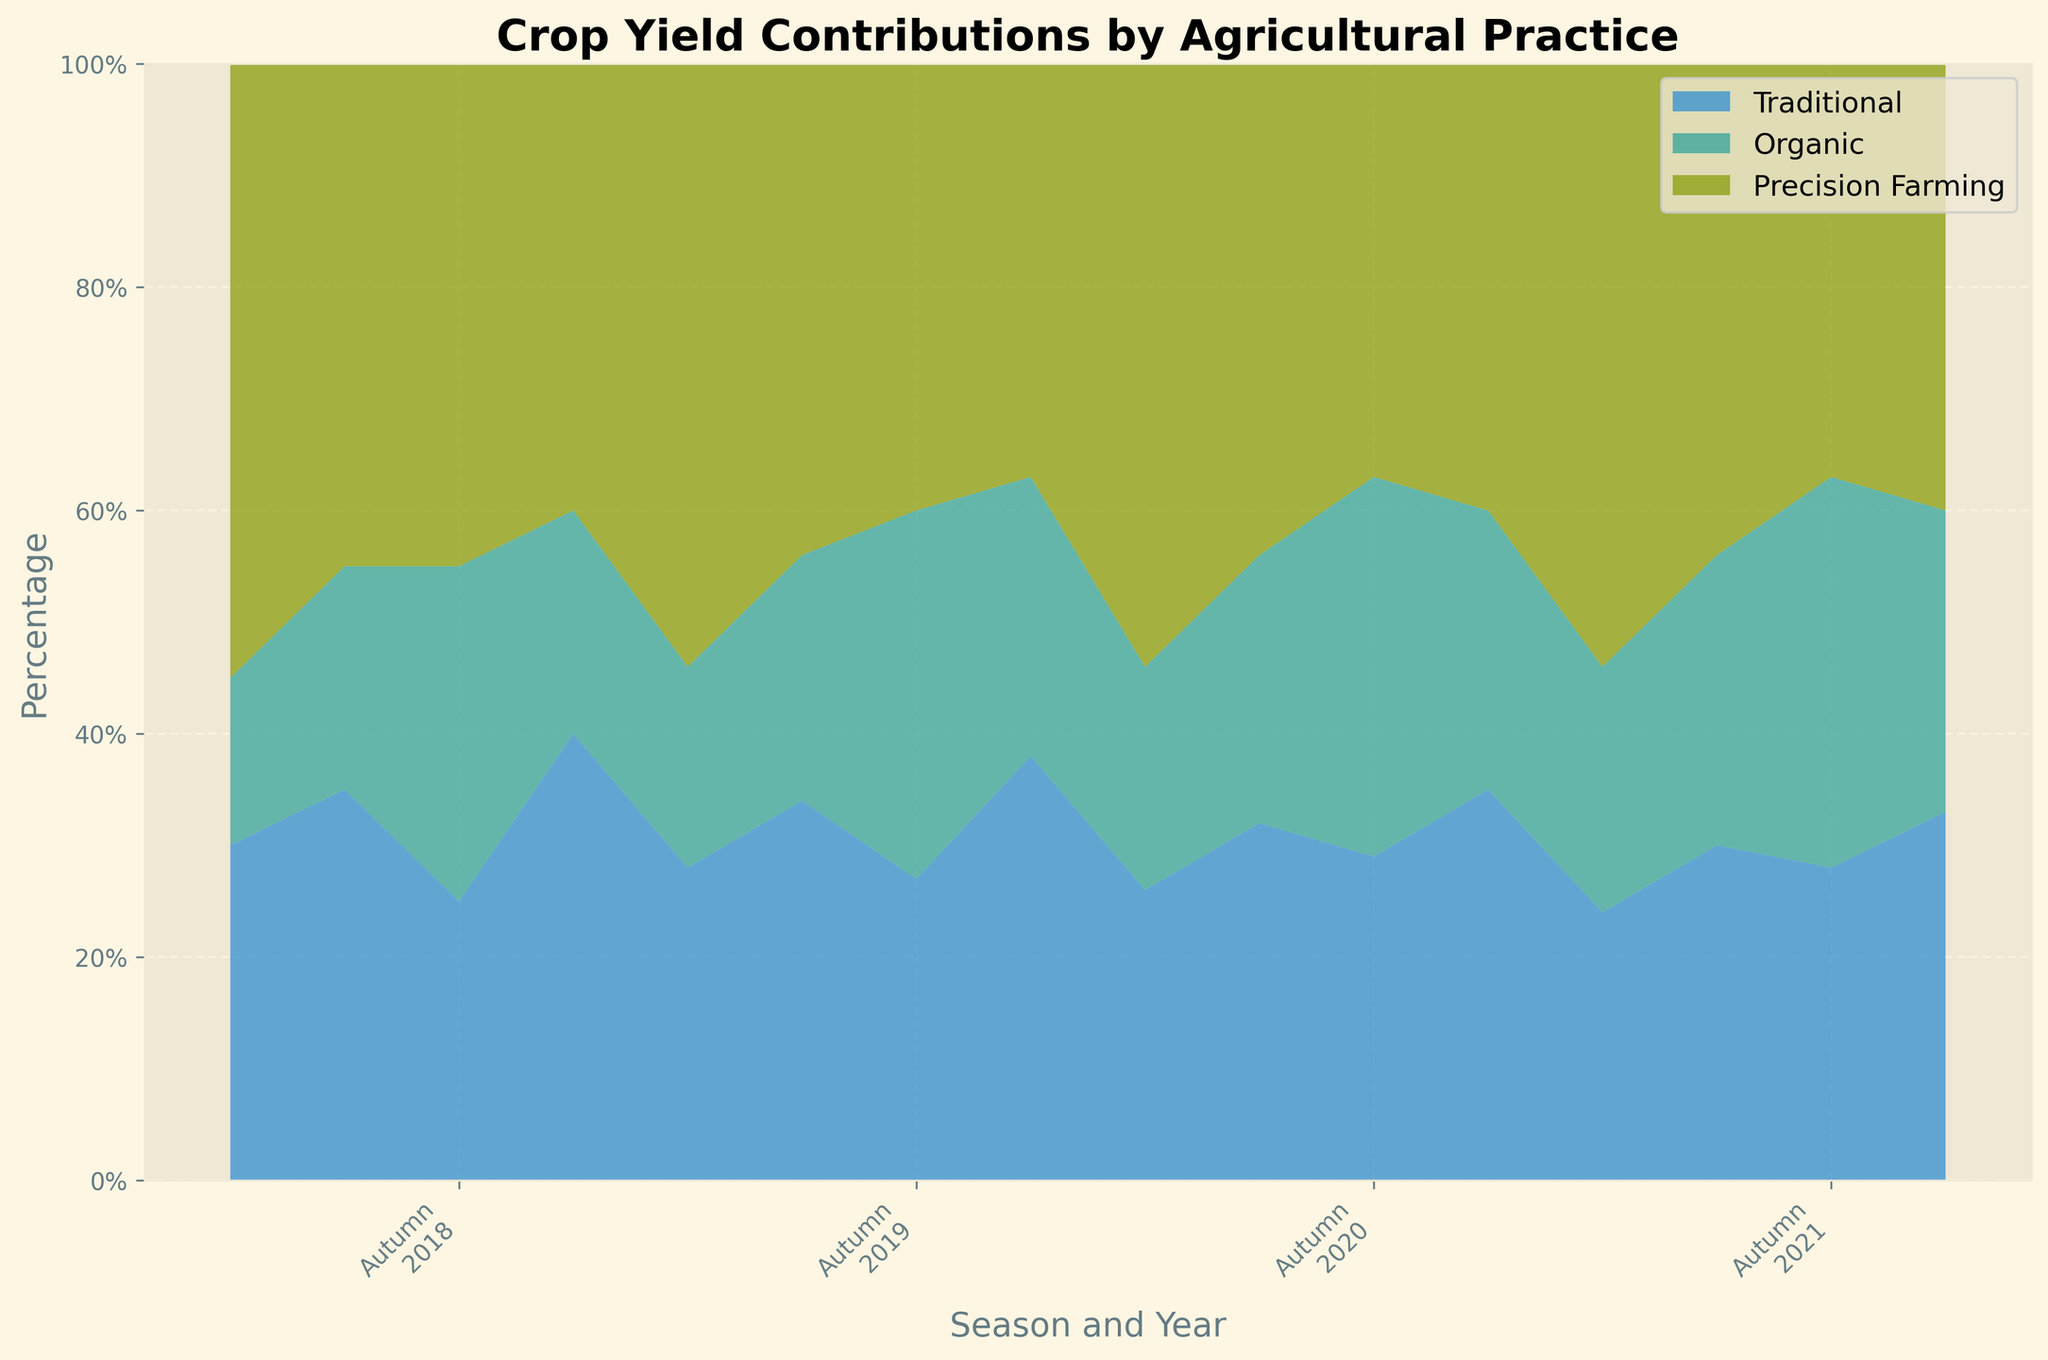What is the title of the chart? The title is usually found at the top of the chart. It provides a brief description of what the chart is about. In this case, the title is "Crop Yield Contributions by Agricultural Practice".
Answer: Crop Yield Contributions by Agricultural Practice Which seasons and years are represented in the x-axis of the chart? Upon examining the x-axis, we can identify that it includes seasons (Spring, Summer, Autumn, Winter) and years (2018, 2019, 2020, 2021).
Answer: Spring, Summer, Autumn, Winter for the years 2018, 2019, 2020, 2021 What are the colors used to represent Traditional, Organic, and Precision Farming practices? By looking at the legend on the chart, we can determine which colors correspond to each agricultural practice. Traditional, Organic, and Precision Farming are usually represented by different shades in the stacked area chart.
Answer: Light color for Traditional, medium color for Organic, dark color for Precision Farming Which agricultural practice contributed the most to crop yields during Spring 2020? The heights of different segments in the stacked area chart vary based on seasons and years. For Spring 2020, the largest section (in height) corresponds to Precision Farming.
Answer: Precision Farming How does the contribution of Precision Farming change from Autumn 2019 to Winter 2019? By comparing the heights of the Precision Farming segments for Autumn 2019 and Winter 2019, we observe that the contribution decreases between these seasons.
Answer: Decreases What is the trend in Traditional practices from Spring 2018 to Spring 2021? Observing Traditional practice segments in Spring seasons from 2018 to 2021 shows that the height of the area generally decreases over these periods.
Answer: Decreasing Between which two seasons did Organic practices show the largest increase in contributions for the year 2019? By comparing the heights of the Organic segments for different seasons in 2019, we can find that the largest increase occurred between Summer 2019 and Autumn 2019.
Answer: Summer 2019 and Autumn 2019 Comparing Spring 2019 and Spring 2020, which practice showed the least change in contribution? By analyzing the differences in segment heights for each practice between Spring 2019 and Spring 2020, we identify that Precision Farming showed the least change.
Answer: Precision Farming 